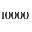<formula> <loc_0><loc_0><loc_500><loc_500>1 0 0 0 0</formula> 